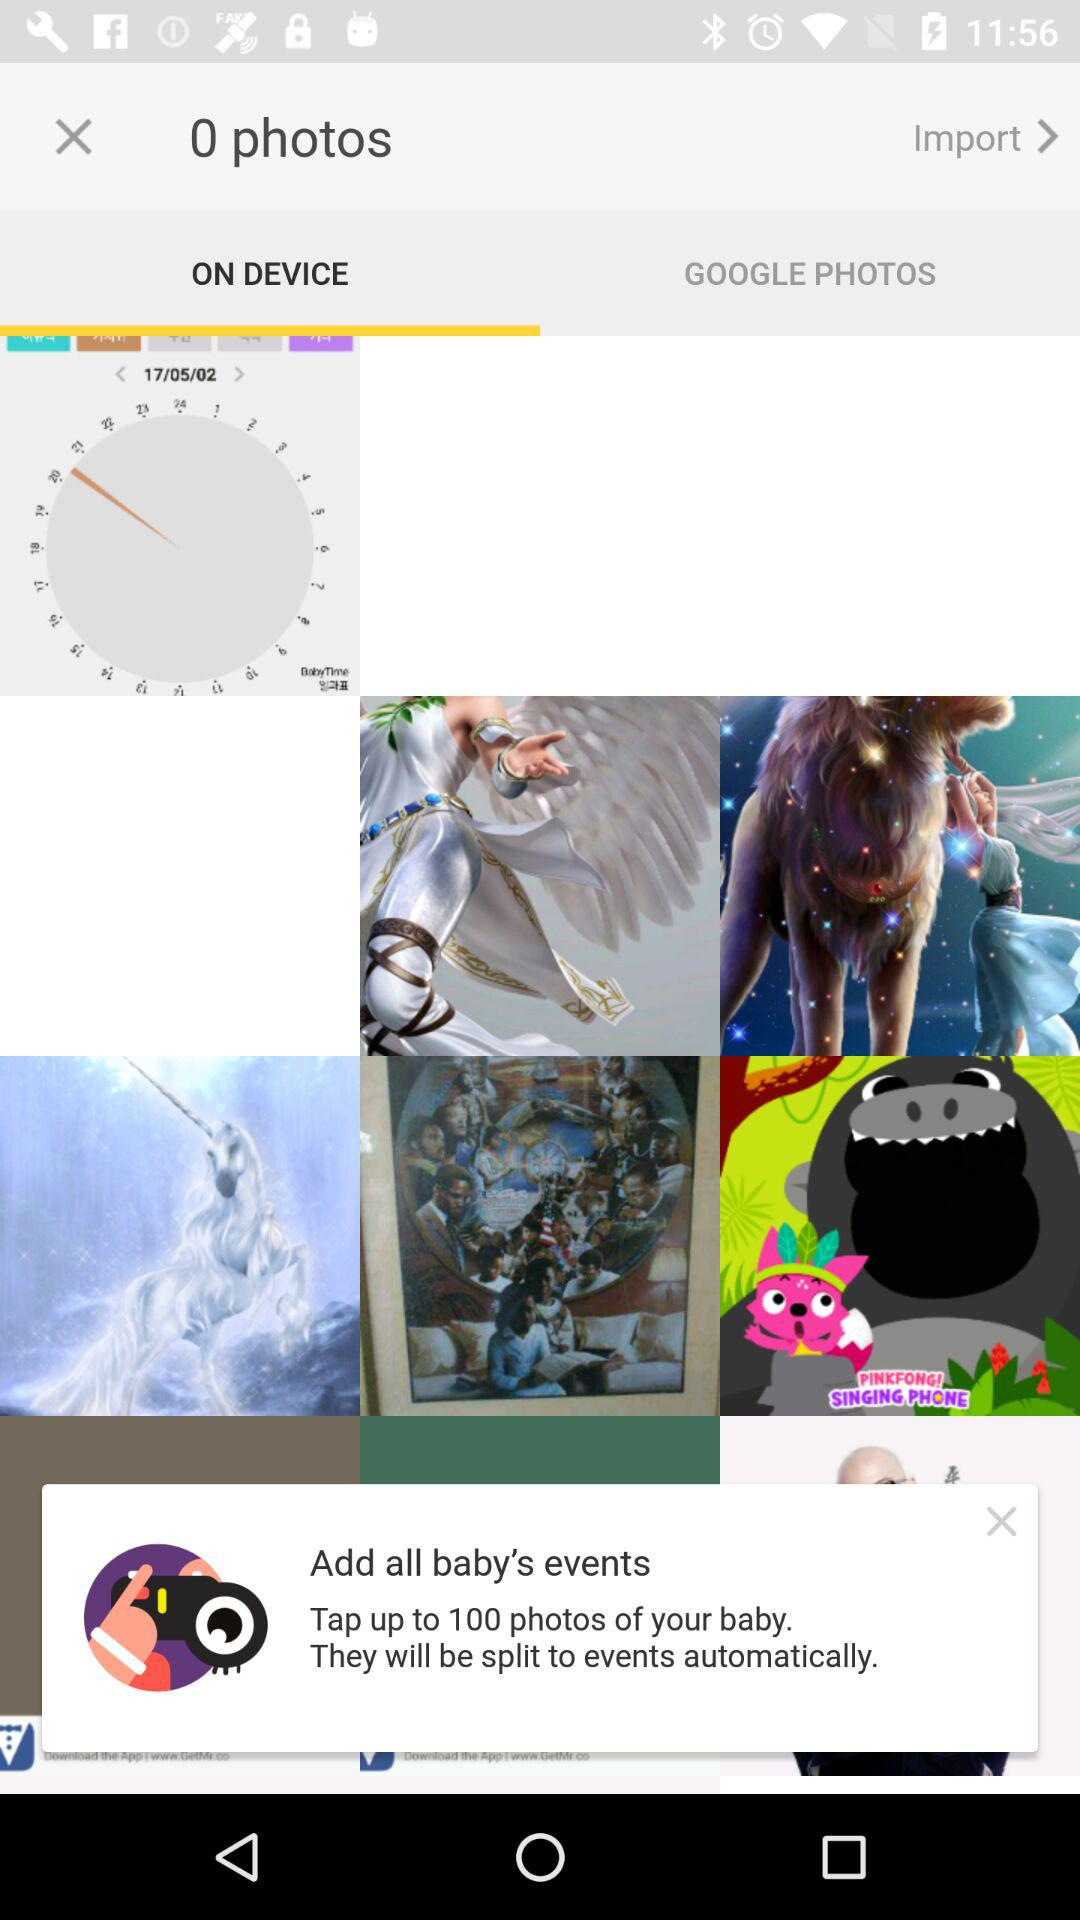What is the total number of photos? There are 0 photos. 